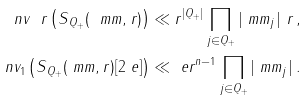Convert formula to latex. <formula><loc_0><loc_0><loc_500><loc_500>\ n v _ { \ } r \left ( S _ { \, Q _ { + } } ( \ m m , r ) \right ) & \ll r ^ { | Q _ { + } | } \prod _ { j \in Q _ { + } } | \ m m _ { j } | ^ { \ } r \, , \\ \ n v _ { 1 } \left ( S _ { \, Q _ { + } } ( \ m m , r ) [ 2 \ e ] \right ) & \ll \ e r ^ { n - 1 } \prod _ { j \in Q _ { + } } | \ m m _ { j } | \, .</formula> 